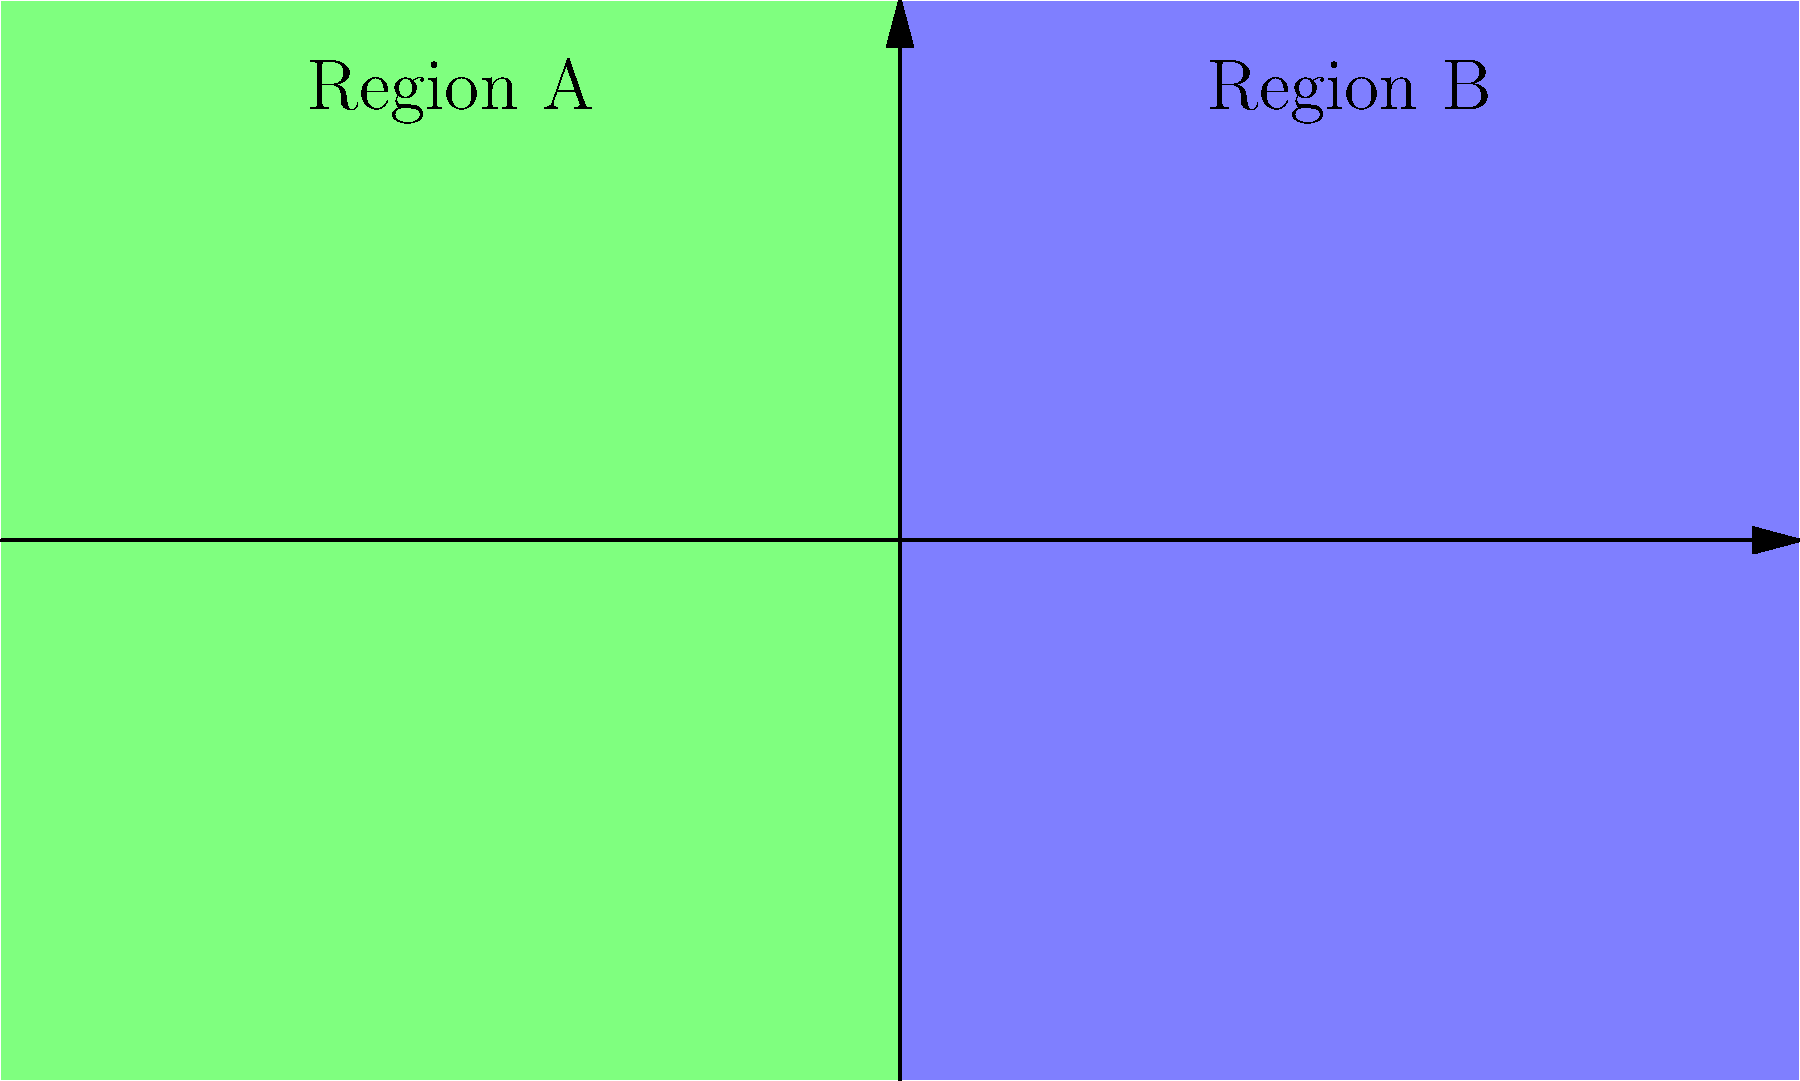Based on the insect distribution map shown, which of the following statements is most accurate regarding the habitat preference of Species X? To interpret the insect distribution map and determine the habitat preference of Species X, we need to follow these steps:

1. Identify the regions: The map is divided into two distinct regions, A and B.

2. Observe the distribution of red dots: These represent the locations where Species X has been found.

3. Count the number of red dots in each region:
   - Region A (left, green): Contains 7 red dots
   - Region B (right, blue): Contains 0 red dots

4. Compare the distribution:
   - Species X is exclusively found in Region A
   - No individuals of Species X are observed in Region B

5. Interpret the habitat preference:
   - The strong presence in Region A and complete absence in Region B suggests that Species X has a strong preference for the environmental conditions present in Region A.

6. Consider possible factors:
   - The boundary between regions could represent a geographical feature (e.g., mountain range, river) or a change in environmental conditions (e.g., temperature, humidity, vegetation type).

Based on this analysis, we can conclude that Species X shows a clear preference for the habitat conditions present in Region A, avoiding Region B entirely.
Answer: Species X strongly prefers Region A habitat. 